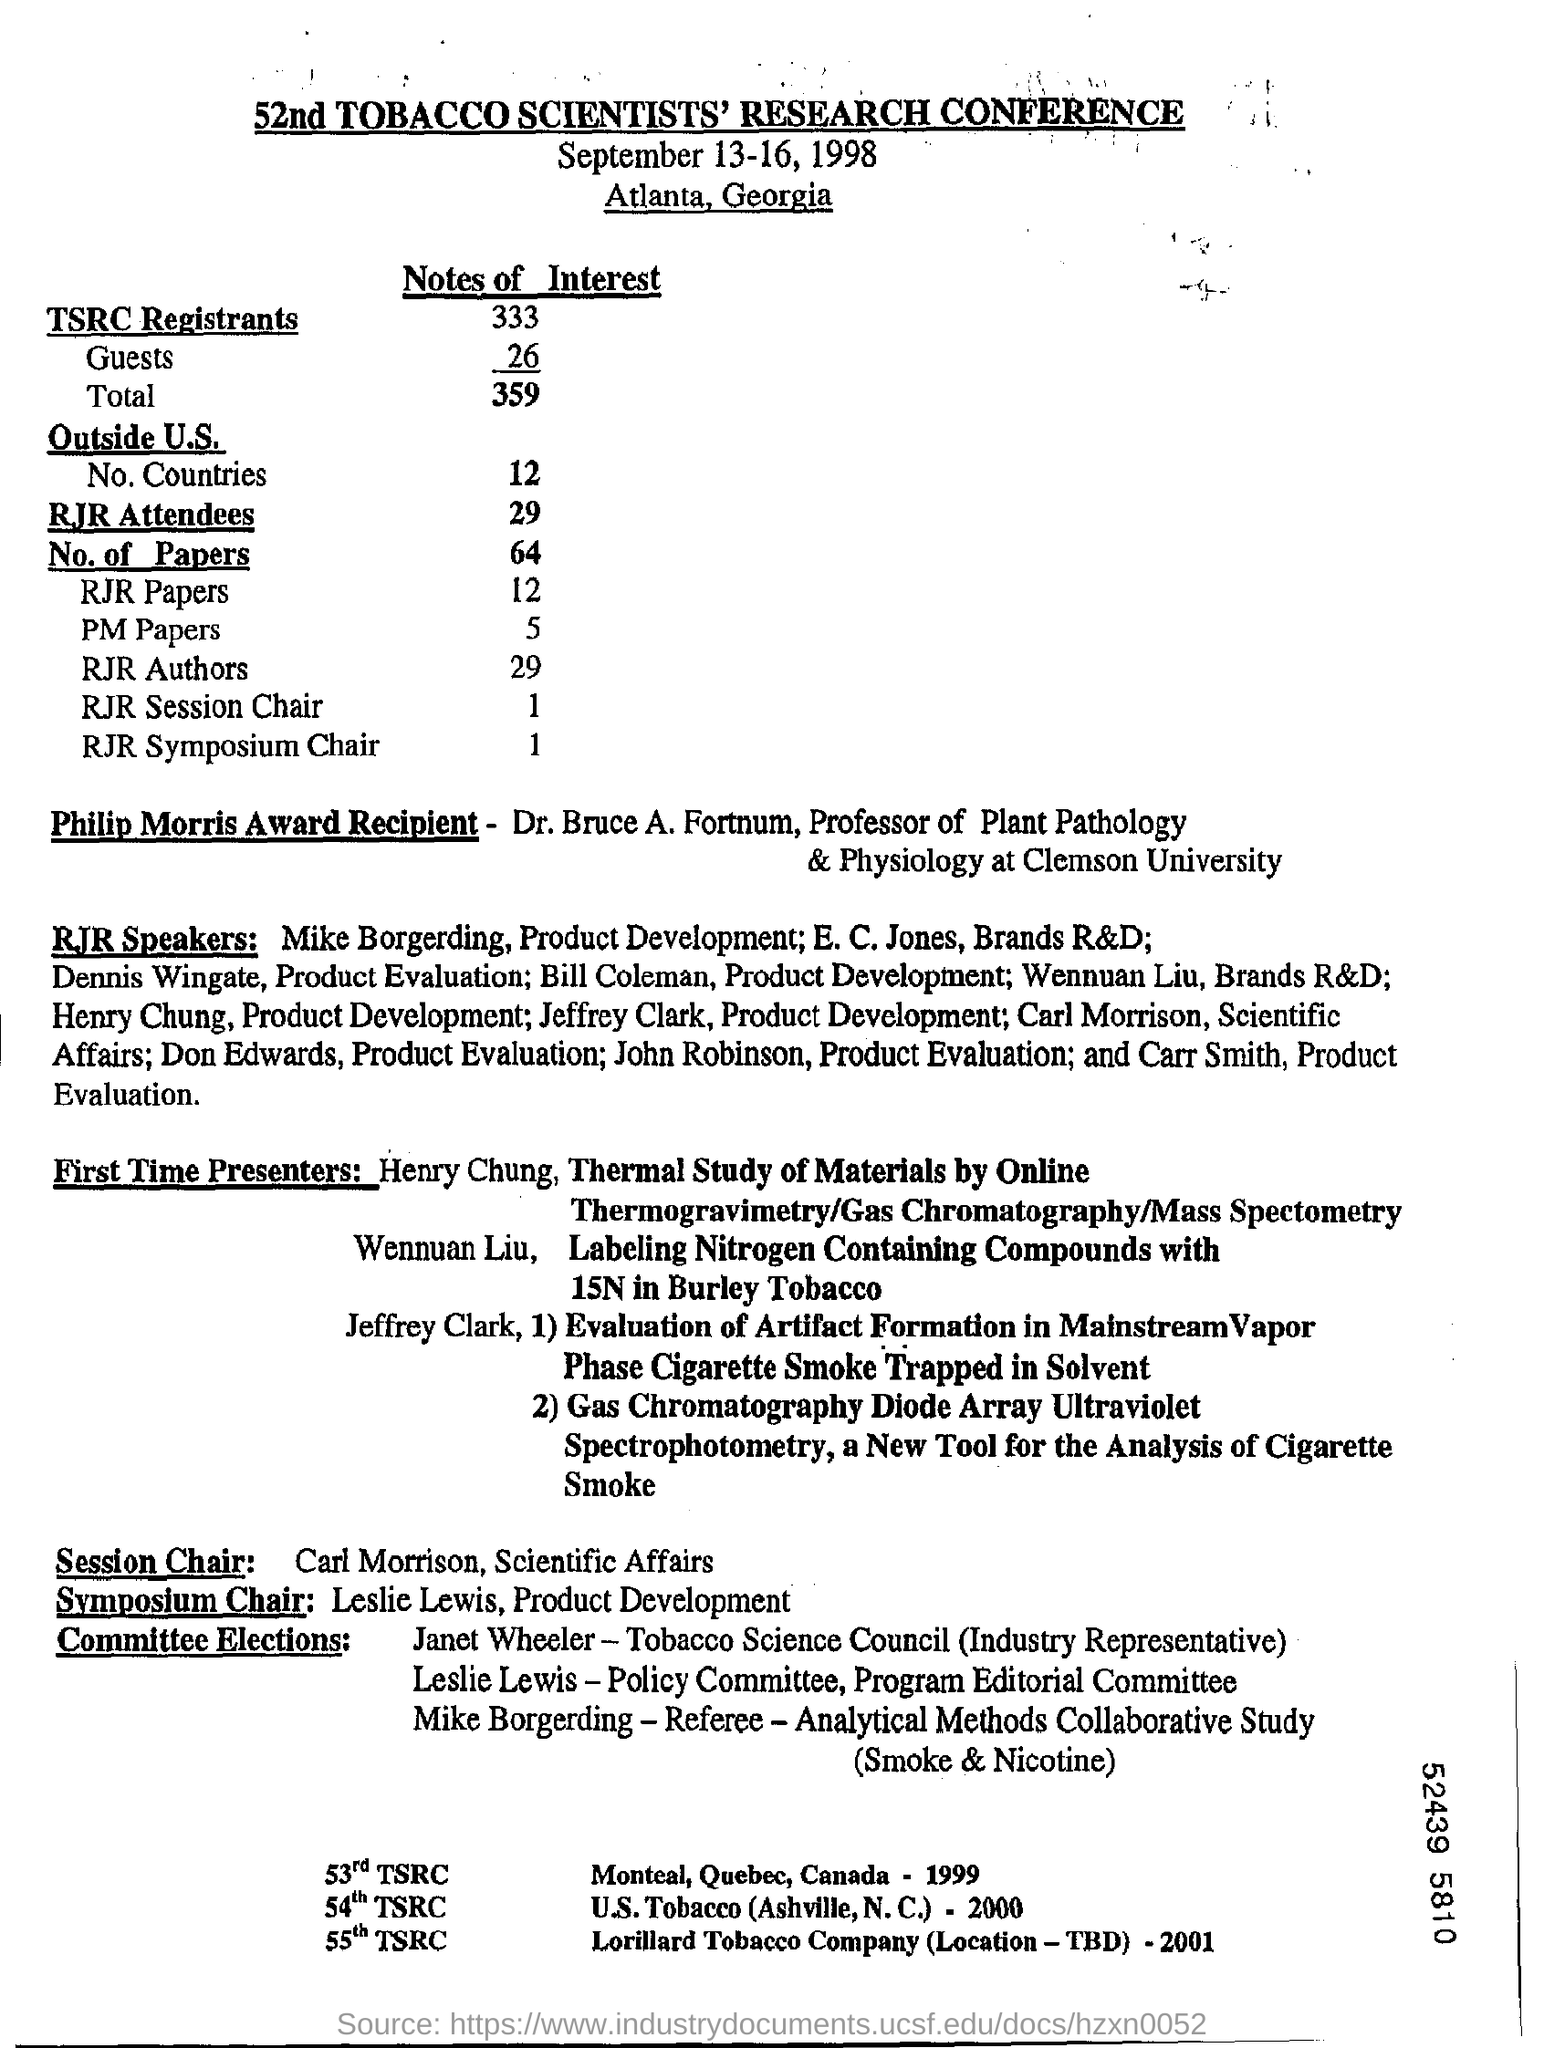What is the Title of the document ?
Provide a short and direct response. 52nd TOBACCO SCIENTISTS' RESEARCH CONFERENCE. What is the date mentioned in the top of the document ?
Keep it short and to the point. September 13-16, 1998. 